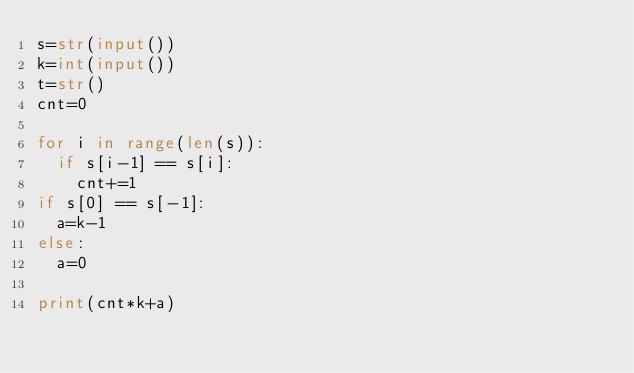Convert code to text. <code><loc_0><loc_0><loc_500><loc_500><_Python_>s=str(input())
k=int(input())
t=str()
cnt=0

for i in range(len(s)):
  if s[i-1] == s[i]:
    cnt+=1
if s[0] == s[-1]:
  a=k-1
else:
  a=0

print(cnt*k+a)</code> 